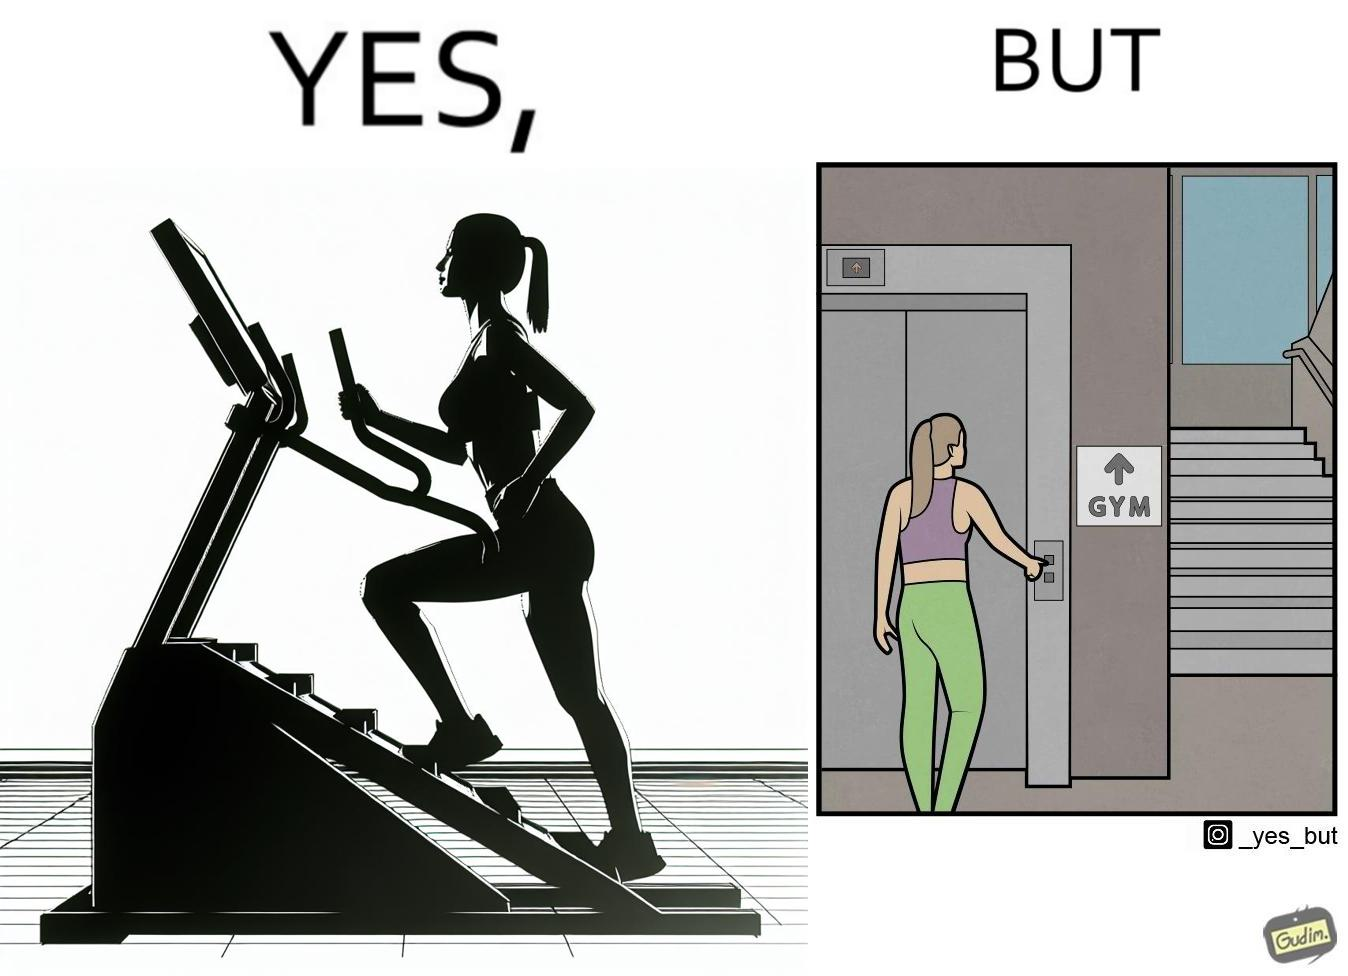Is there satirical content in this image? Yes, this image is satirical. 